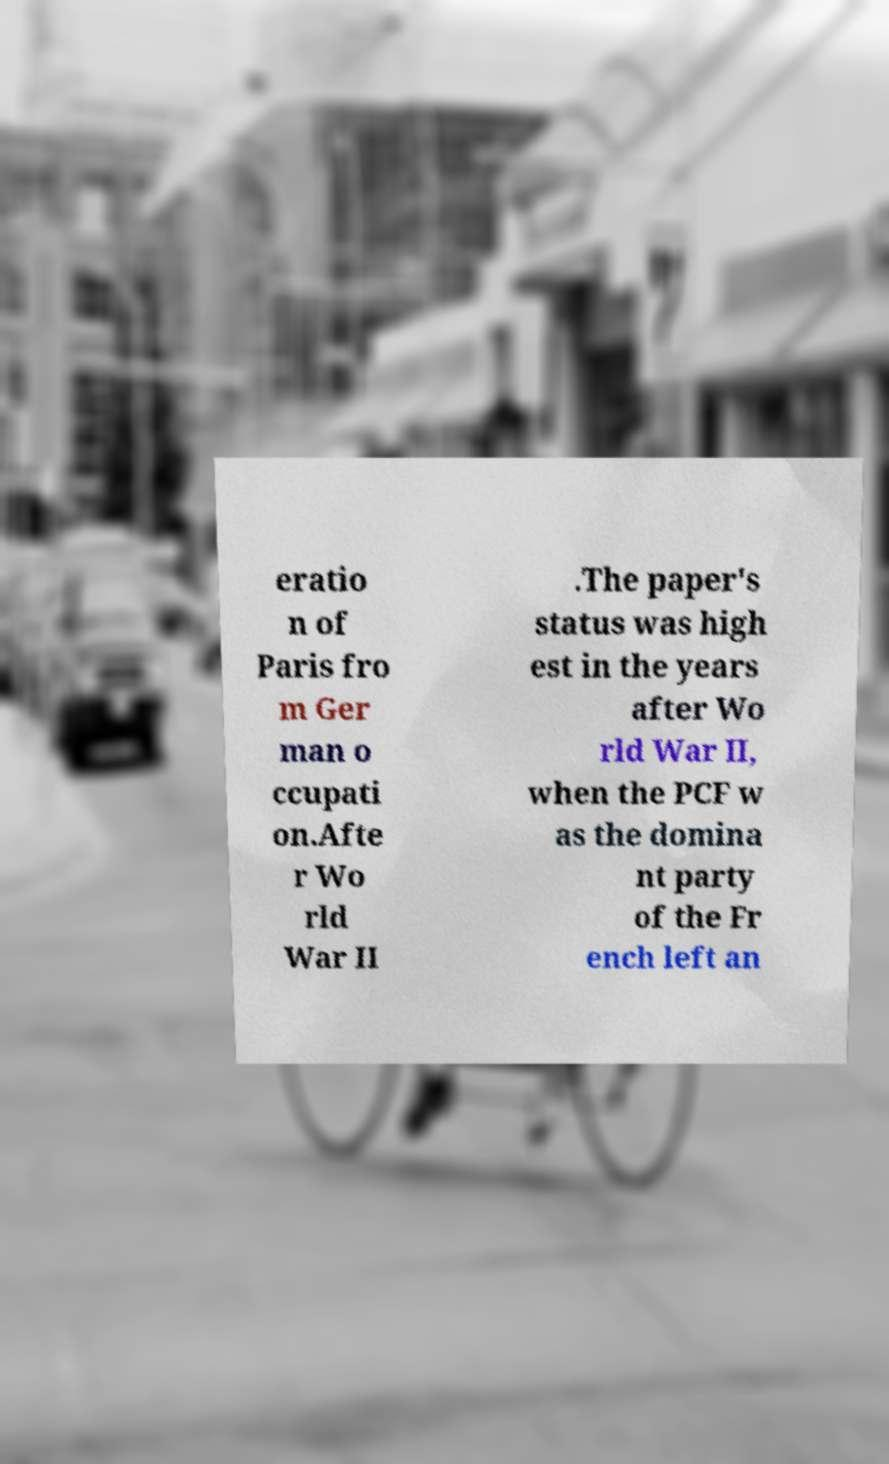Please read and relay the text visible in this image. What does it say? eratio n of Paris fro m Ger man o ccupati on.Afte r Wo rld War II .The paper's status was high est in the years after Wo rld War II, when the PCF w as the domina nt party of the Fr ench left an 